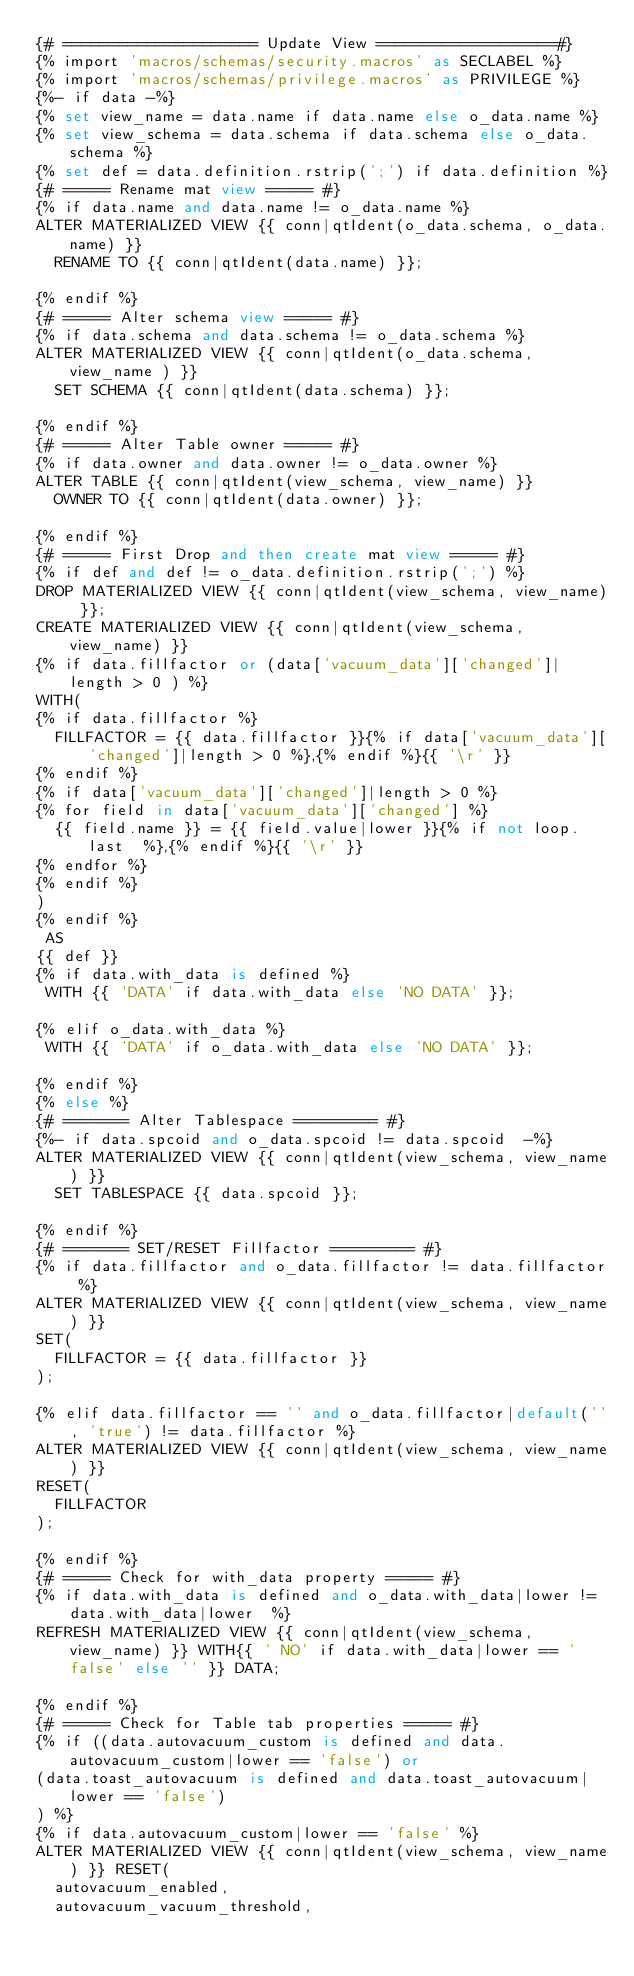<code> <loc_0><loc_0><loc_500><loc_500><_SQL_>{# ===================== Update View ===================#}
{% import 'macros/schemas/security.macros' as SECLABEL %}
{% import 'macros/schemas/privilege.macros' as PRIVILEGE %}
{%- if data -%}
{% set view_name = data.name if data.name else o_data.name %}
{% set view_schema = data.schema if data.schema else o_data.schema %}
{% set def = data.definition.rstrip(';') if data.definition %}
{# ===== Rename mat view ===== #}
{% if data.name and data.name != o_data.name %}
ALTER MATERIALIZED VIEW {{ conn|qtIdent(o_data.schema, o_data.name) }}
  RENAME TO {{ conn|qtIdent(data.name) }};

{% endif %}
{# ===== Alter schema view ===== #}
{% if data.schema and data.schema != o_data.schema %}
ALTER MATERIALIZED VIEW {{ conn|qtIdent(o_data.schema, view_name ) }}
  SET SCHEMA {{ conn|qtIdent(data.schema) }};

{% endif %}
{# ===== Alter Table owner ===== #}
{% if data.owner and data.owner != o_data.owner %}
ALTER TABLE {{ conn|qtIdent(view_schema, view_name) }}
  OWNER TO {{ conn|qtIdent(data.owner) }};

{% endif %}
{# ===== First Drop and then create mat view ===== #}
{% if def and def != o_data.definition.rstrip(';') %}
DROP MATERIALIZED VIEW {{ conn|qtIdent(view_schema, view_name) }};
CREATE MATERIALIZED VIEW {{ conn|qtIdent(view_schema, view_name) }}
{% if data.fillfactor or (data['vacuum_data']['changed']|length > 0 ) %}
WITH(
{% if data.fillfactor %}
  FILLFACTOR = {{ data.fillfactor }}{% if data['vacuum_data']['changed']|length > 0 %},{% endif %}{{ '\r' }}
{% endif %}
{% if data['vacuum_data']['changed']|length > 0 %}
{% for field in data['vacuum_data']['changed'] %}
  {{ field.name }} = {{ field.value|lower }}{% if not loop.last  %},{% endif %}{{ '\r' }}
{% endfor %}
{% endif %}
)
{% endif %}
 AS
{{ def }}
{% if data.with_data is defined %}
 WITH {{ 'DATA' if data.with_data else 'NO DATA' }};

{% elif o_data.with_data %}
 WITH {{ 'DATA' if o_data.with_data else 'NO DATA' }};

{% endif %}
{% else %}
{# ======= Alter Tablespace ========= #}
{%- if data.spcoid and o_data.spcoid != data.spcoid  -%}
ALTER MATERIALIZED VIEW {{ conn|qtIdent(view_schema, view_name) }}
  SET TABLESPACE {{ data.spcoid }};

{% endif %}
{# ======= SET/RESET Fillfactor ========= #}
{% if data.fillfactor and o_data.fillfactor != data.fillfactor %}
ALTER MATERIALIZED VIEW {{ conn|qtIdent(view_schema, view_name) }}
SET(
  FILLFACTOR = {{ data.fillfactor }}
);

{% elif data.fillfactor == '' and o_data.fillfactor|default('', 'true') != data.fillfactor %}
ALTER MATERIALIZED VIEW {{ conn|qtIdent(view_schema, view_name) }}
RESET(
  FILLFACTOR
);

{% endif %}
{# ===== Check for with_data property ===== #}
{% if data.with_data is defined and o_data.with_data|lower != data.with_data|lower  %}
REFRESH MATERIALIZED VIEW {{ conn|qtIdent(view_schema, view_name) }} WITH{{ ' NO' if data.with_data|lower == 'false' else '' }} DATA;

{% endif %}
{# ===== Check for Table tab properties ===== #}
{% if ((data.autovacuum_custom is defined and data.autovacuum_custom|lower == 'false') or
(data.toast_autovacuum is defined and data.toast_autovacuum|lower == 'false')
) %}
{% if data.autovacuum_custom|lower == 'false' %}
ALTER MATERIALIZED VIEW {{ conn|qtIdent(view_schema, view_name) }} RESET(
  autovacuum_enabled,
  autovacuum_vacuum_threshold,</code> 